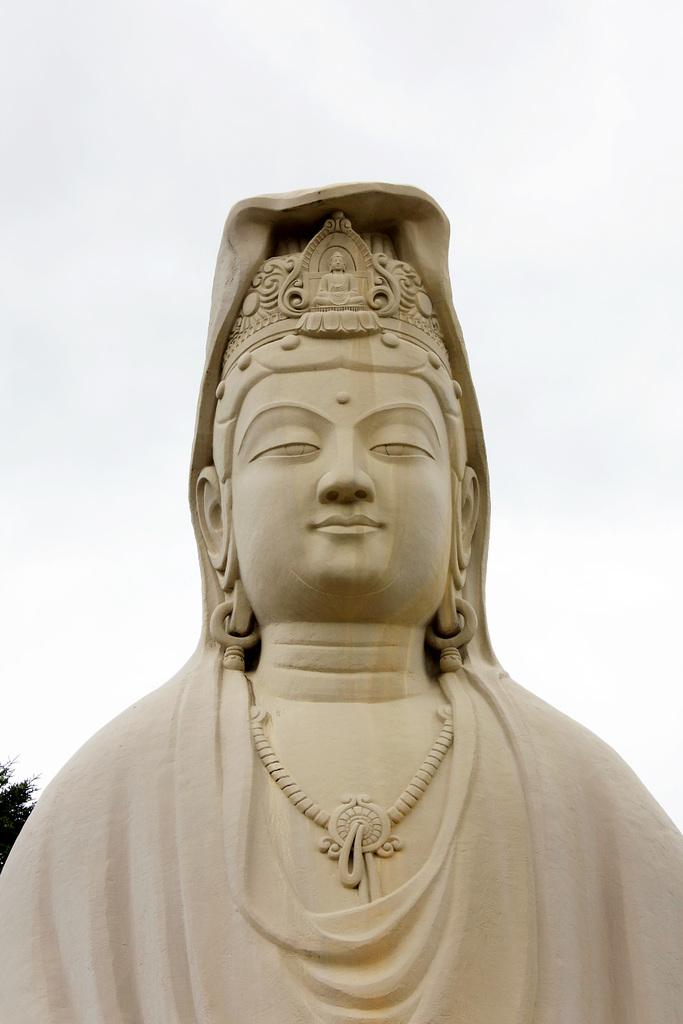What is the main subject of the picture? The main subject of the picture is an idol of a goddess. What architectural features can be seen on the idol? The idol has some architectural features. What color is the idol? The idol is cream in color. What natural elements are visible in the image? There is a part of a tree visible behind the idol, and the sky is visible in the background of the image. What type of patch can be seen on the moon in the image? There is no moon visible in the image, and therefore no patch can be seen on it. What discovery was made by the idol in the image? The idol is a statue and does not make discoveries. 